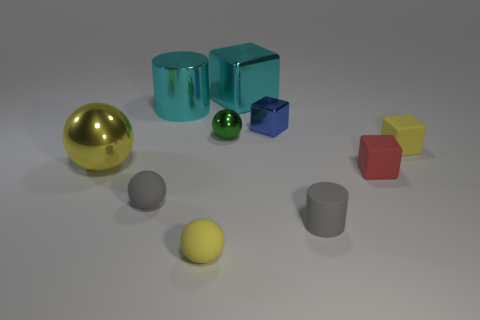Do the large block and the large metal cylinder have the same color?
Your response must be concise. Yes. Are there fewer gray matte spheres than small cyan rubber objects?
Provide a short and direct response. No. What number of other things are there of the same color as the shiny cylinder?
Ensure brevity in your answer.  1. How many yellow objects are there?
Ensure brevity in your answer.  3. Are there fewer red matte things that are behind the red object than large brown shiny cylinders?
Your response must be concise. No. Do the cylinder on the right side of the blue thing and the red cube have the same material?
Provide a succinct answer. Yes. The yellow object behind the large shiny thing that is in front of the small metal thing in front of the tiny blue metallic cube is what shape?
Give a very brief answer. Cube. Is there a yellow rubber sphere of the same size as the red object?
Give a very brief answer. Yes. The yellow metallic ball is what size?
Your answer should be compact. Large. How many rubber spheres are the same size as the yellow matte block?
Make the answer very short. 2. 